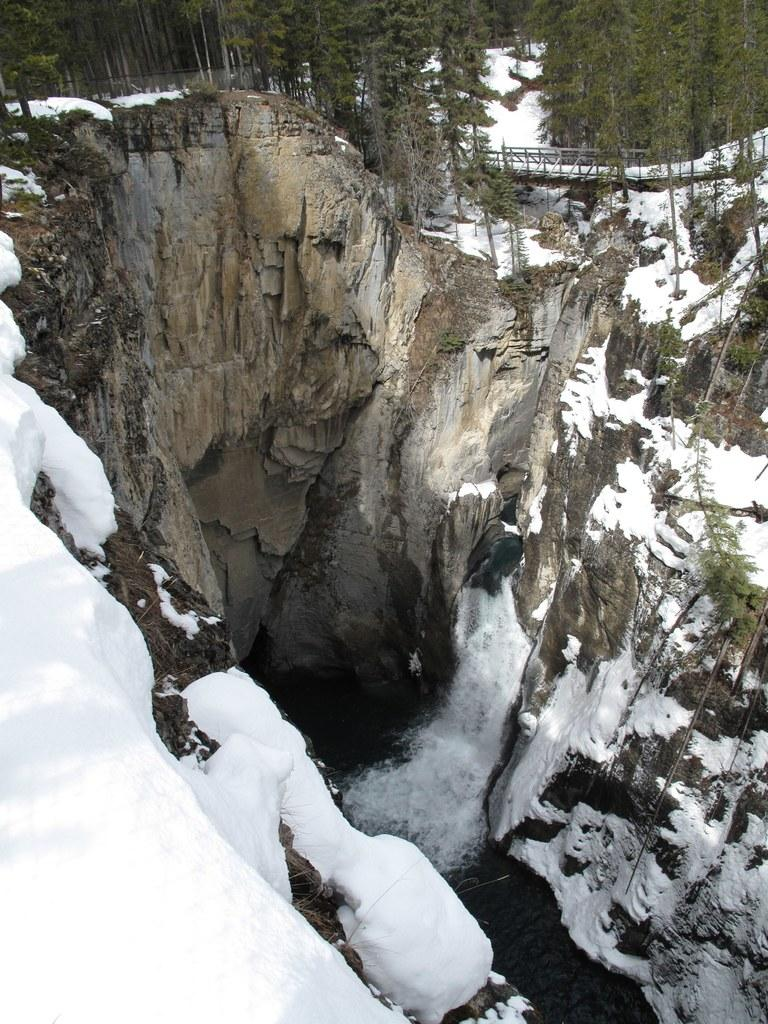What geographical feature is located in the middle of the image? There is a valley in the middle of the image. What type of vegetation can be seen at the top of the image? There are trees at the top of the image. How many stitches are visible on the trees in the image? There are no stitches visible on the trees in the image, as trees do not have stitches. 